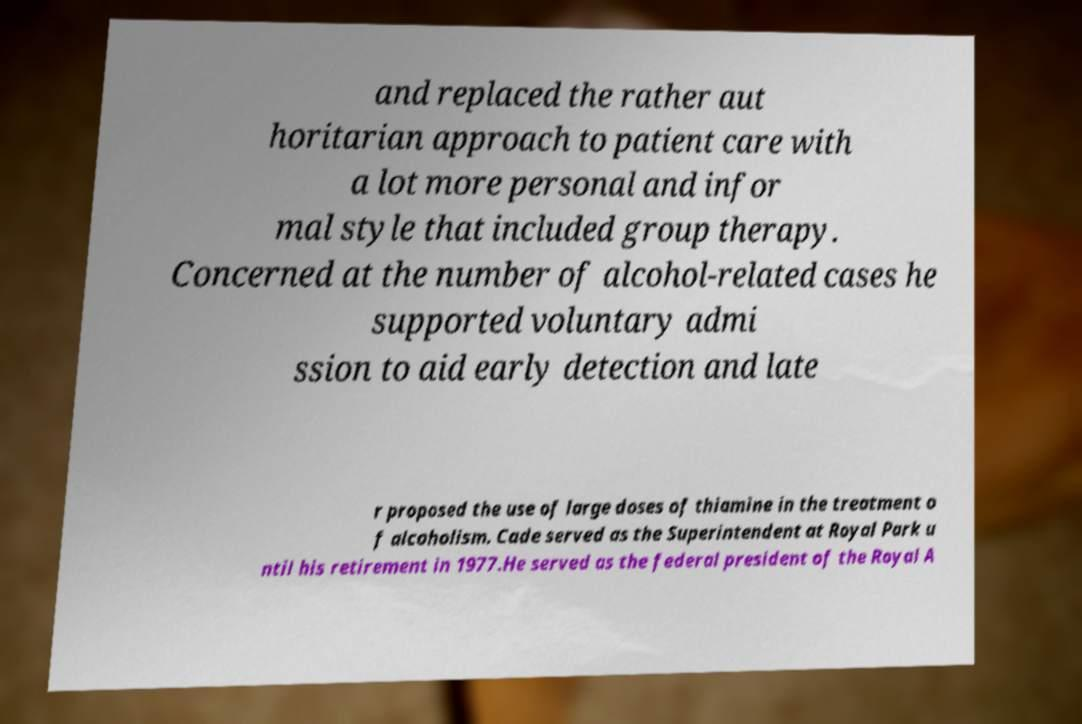Please identify and transcribe the text found in this image. and replaced the rather aut horitarian approach to patient care with a lot more personal and infor mal style that included group therapy. Concerned at the number of alcohol-related cases he supported voluntary admi ssion to aid early detection and late r proposed the use of large doses of thiamine in the treatment o f alcoholism. Cade served as the Superintendent at Royal Park u ntil his retirement in 1977.He served as the federal president of the Royal A 